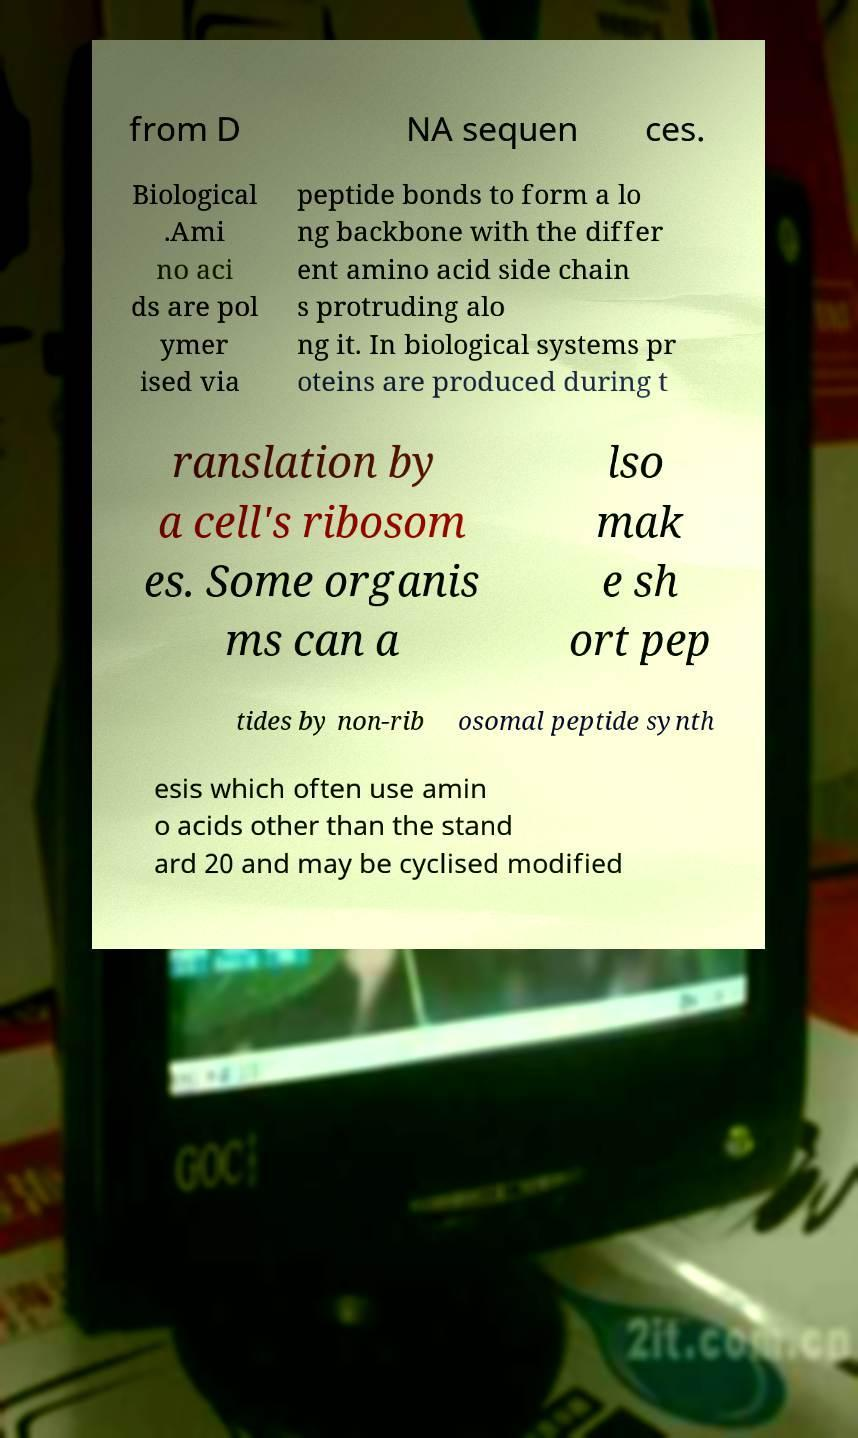Can you read and provide the text displayed in the image?This photo seems to have some interesting text. Can you extract and type it out for me? from D NA sequen ces. Biological .Ami no aci ds are pol ymer ised via peptide bonds to form a lo ng backbone with the differ ent amino acid side chain s protruding alo ng it. In biological systems pr oteins are produced during t ranslation by a cell's ribosom es. Some organis ms can a lso mak e sh ort pep tides by non-rib osomal peptide synth esis which often use amin o acids other than the stand ard 20 and may be cyclised modified 